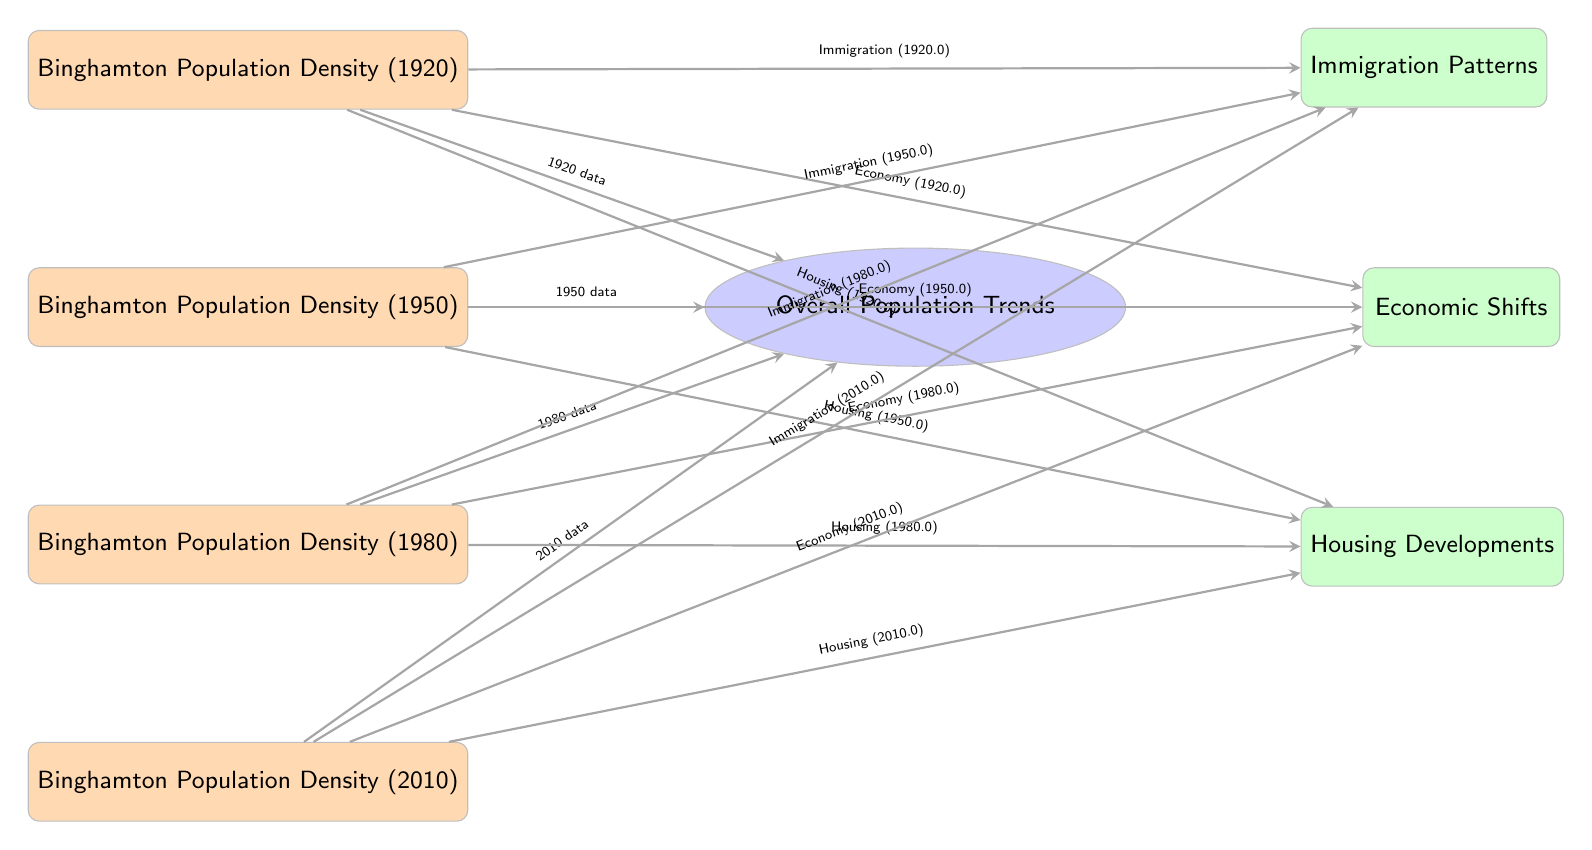What is the population density for Binghamton in 1920? The node labeled "Binghamton Population Density (1920)" provides the value for the population density in that year.
Answer: Binghamton Population Density (1920) Which year shows the highest population density in the heatmap series? By comparing the labels on the heatmap nodes, we identify that the nodes list population density for the years 1920, 1950, 1980, and 2010. The visual representation suggests that later years generally show trends of higher density.
Answer: 2010 How many total heatmap nodes are there in the diagram? The diagram contains four heatmap nodes representing the population density for the years specified; counting these nodes gives the total number.
Answer: 4 What ties together immigration patterns, economic shifts, and housing developments in this diagram? The arrows from each heatmap indicate that all three aspects are influenced by the population density data shown in the heatmap nodes, creating a connection between them.
Answer: Population Density What relationship does the 1950 population density data have with economic shifts? The arrow connecting the "Binghamton Population Density (1950)" to the "Economic Shifts" node indicates that there is a contribution of the population density data from 1950 that impacts the economic shifts in that timeframe.
Answer: Economic Shifts What aspect connects the immigration patterns from 1980 to population density? The arrow from the heatmap node "Binghamton Population Density (1980)" to the "Immigration Patterns" node indicates that data from that specific year is used to understand the immigration patterns during that period.
Answer: Immigration Patterns In which year does the trend analysis of overall population trends seem to become reliant on the other data points? The arrowing structure suggests that from the year 1920 to 2010, with each passing decade, the overall trends increasingly reflect the information from the preceding year data points.
Answer: 2010 How are housing developments related to population density data? The arrows point from each of the heatmap nodes to the "Housing Developments" node, indicating that changes in population density influence housing development patterns in each time period.
Answer: Housing Developments 